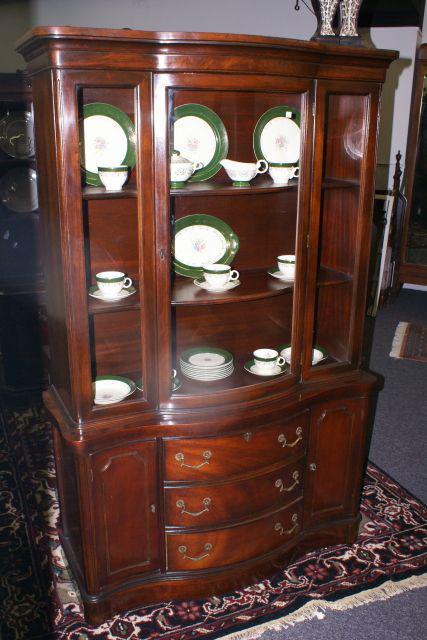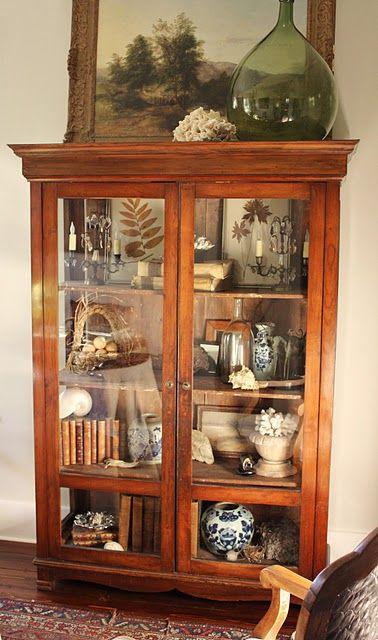The first image is the image on the left, the second image is the image on the right. Evaluate the accuracy of this statement regarding the images: "One china cabinet has three stacked drawers on the bottom and three upper shelves filled with dishes.". Is it true? Answer yes or no. Yes. 